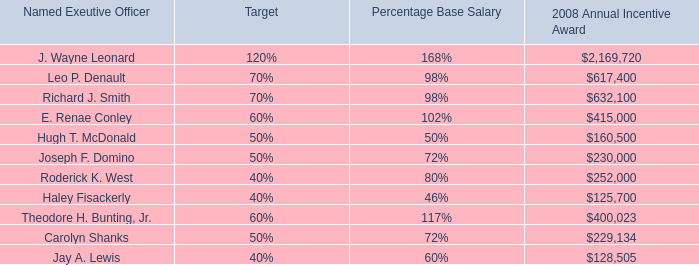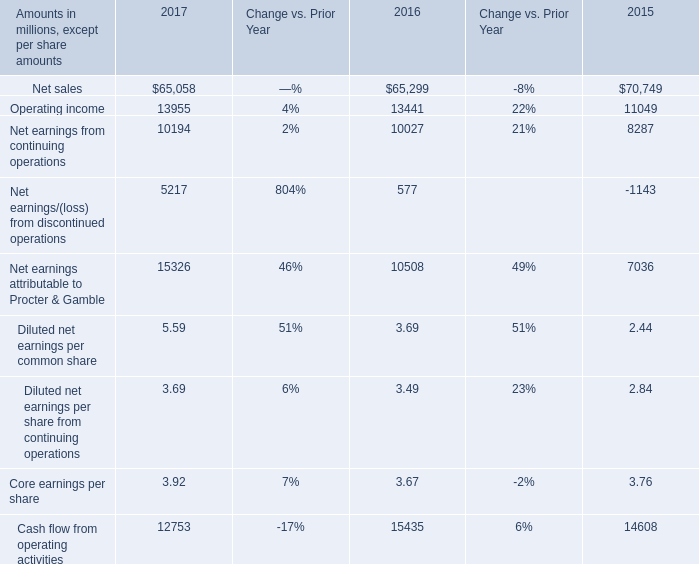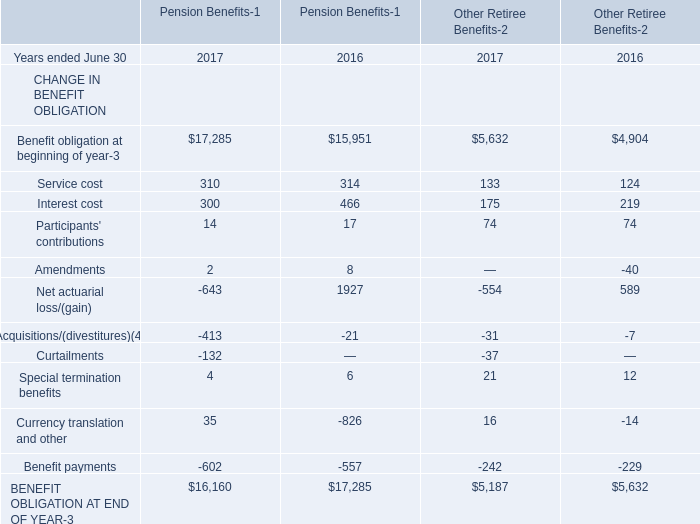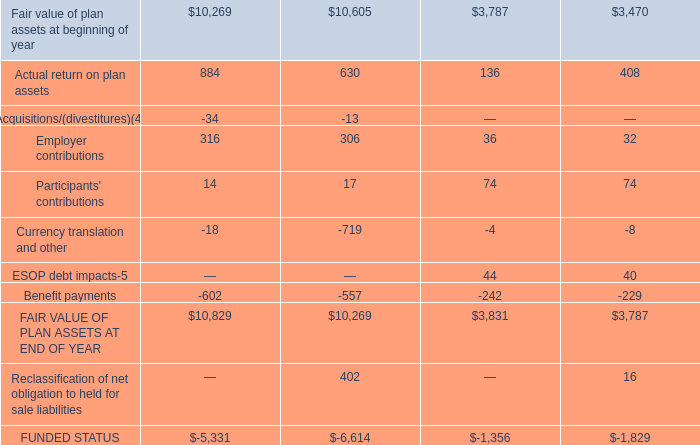what's the total amount of Benefit obligation at beginning of year of Pension Benefits 2017, Theodore H. Bunting, Jr. of 2008 Annual Incentive Award, and BENEFIT OBLIGATION AT END OF YEAR of Other Retiree Benefits 2017 ? 
Computations: ((17285.0 + 400023.0) + 5187.0)
Answer: 422495.0. 